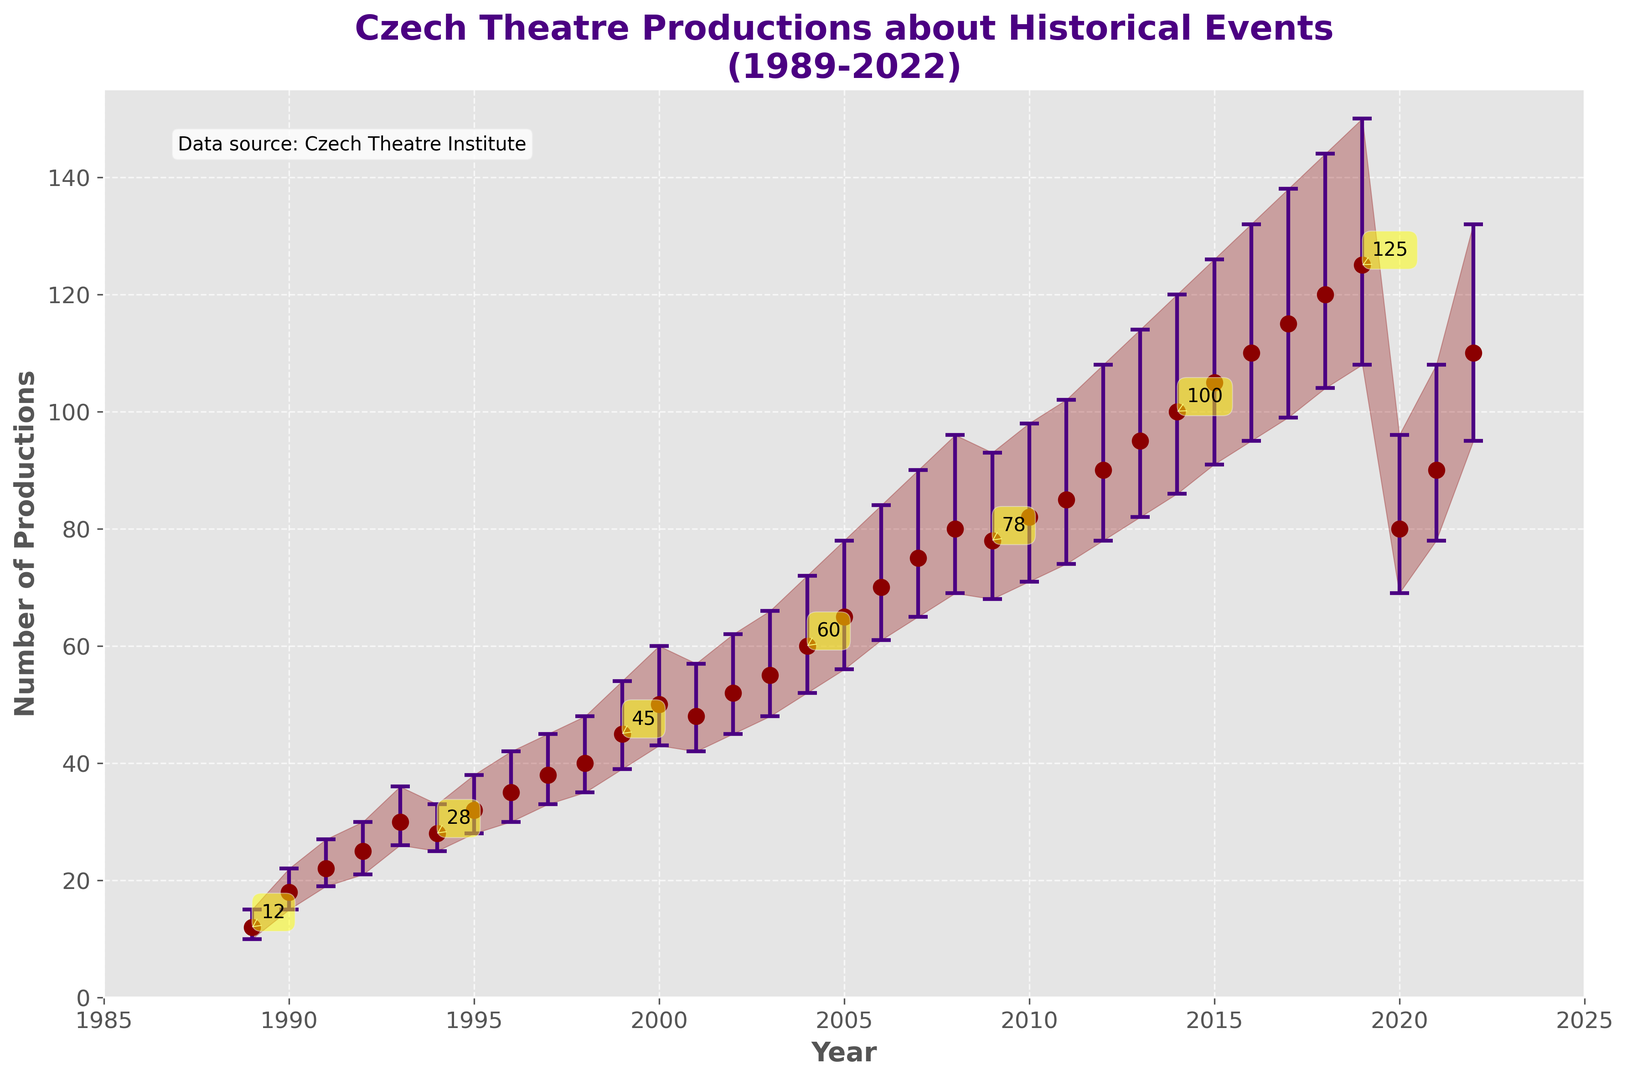How did the number of Czech theatre productions about historical events change from 2008 to 2010? Look at the data points for 2008, 2009, and 2010. In 2008, the number of productions was 80, in 2009, it was 78, and in 2010, it was 82. Therefore, the number initially decreased and then increased slightly.
Answer: Decreased then increased Which year had the highest number of Czech theatre productions about historical events, and what was the number? Look for the year with the highest data point on the plot. The highest number of productions was in 2019 with 125 productions.
Answer: 2019, 125 Between which consecutive years did the number of Czech theatre productions see the largest increase? Look at the differences between each consecutive year’s production numbers. The largest increase appears between 2019 (125 productions) and 2020 (80 productions), giving the largest drop instead of an increase. For the actual largest increase, consider years like 2018 (120 productions) and 2019 (125 productions) which then are not the largest increase either and actually the highest increase is from 2014 (100) to 2015 (105)
Answer: 2014-2015 What was the average number of Czech theatre productions about historical events from 1995 to 2000? Sum the productions for the years 1995 (32), 1996 (35), 1997 (38), 1998 (40), 1999 (45), and 2000 (50) and then divide by the number of years (6). (32 + 35 + 38 + 40 + 45 + 50) / 6 = 240/6 = 40
Answer: 40 How did error estimates change generally from 1989 to 2022? Look at the error bars throughout the years. Initially, the errors were smaller, from 2-3 in 1989, and they increased gradually, reaching errors as high as 15-25 in recent years.
Answer: Increased Which year had the smallest error range and what was it? Identify the year with the smallest difference between ErrorLow and ErrorHigh. The smallest error range was in 1989, where the range was 1.
Answer: 1989, 1 What trend do you observe in the number of productions from 1989 to 2022? The overall trend from 1989 to 2022 shows an increasing number of Czech theatre productions about historical events, with some fluctuations, especially between 2019 and 2020.
Answer: Increasing, with fluctuations In which year do the error bars show the most uncertainty, and what is the range of uncertainty? Look for the year with the largest difference between ErrorLow and ErrorHigh. The greatest range of uncertainty is in 2019, with an error range from 17 to 25.
Answer: 2019, 17-25 